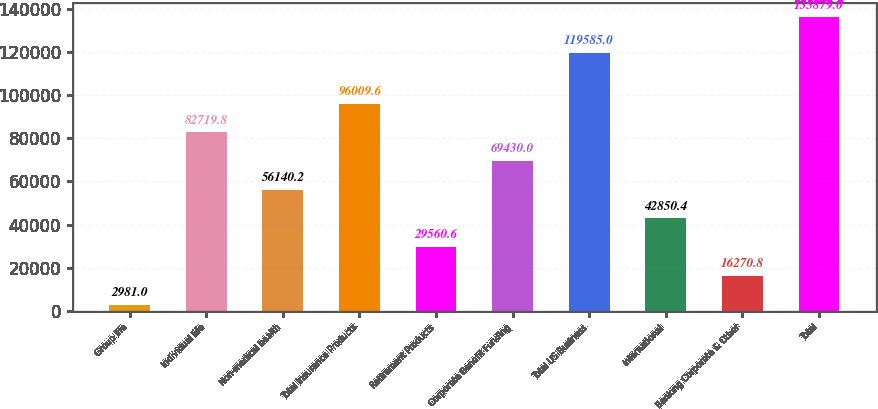Convert chart. <chart><loc_0><loc_0><loc_500><loc_500><bar_chart><fcel>Group life<fcel>Individual life<fcel>Non-medical health<fcel>Total Insurance Products<fcel>Retirement Products<fcel>Corporate Benefit Funding<fcel>Total US Business<fcel>International<fcel>Banking Corporate & Other<fcel>Total<nl><fcel>2981<fcel>82719.8<fcel>56140.2<fcel>96009.6<fcel>29560.6<fcel>69430<fcel>119585<fcel>42850.4<fcel>16270.8<fcel>135879<nl></chart> 